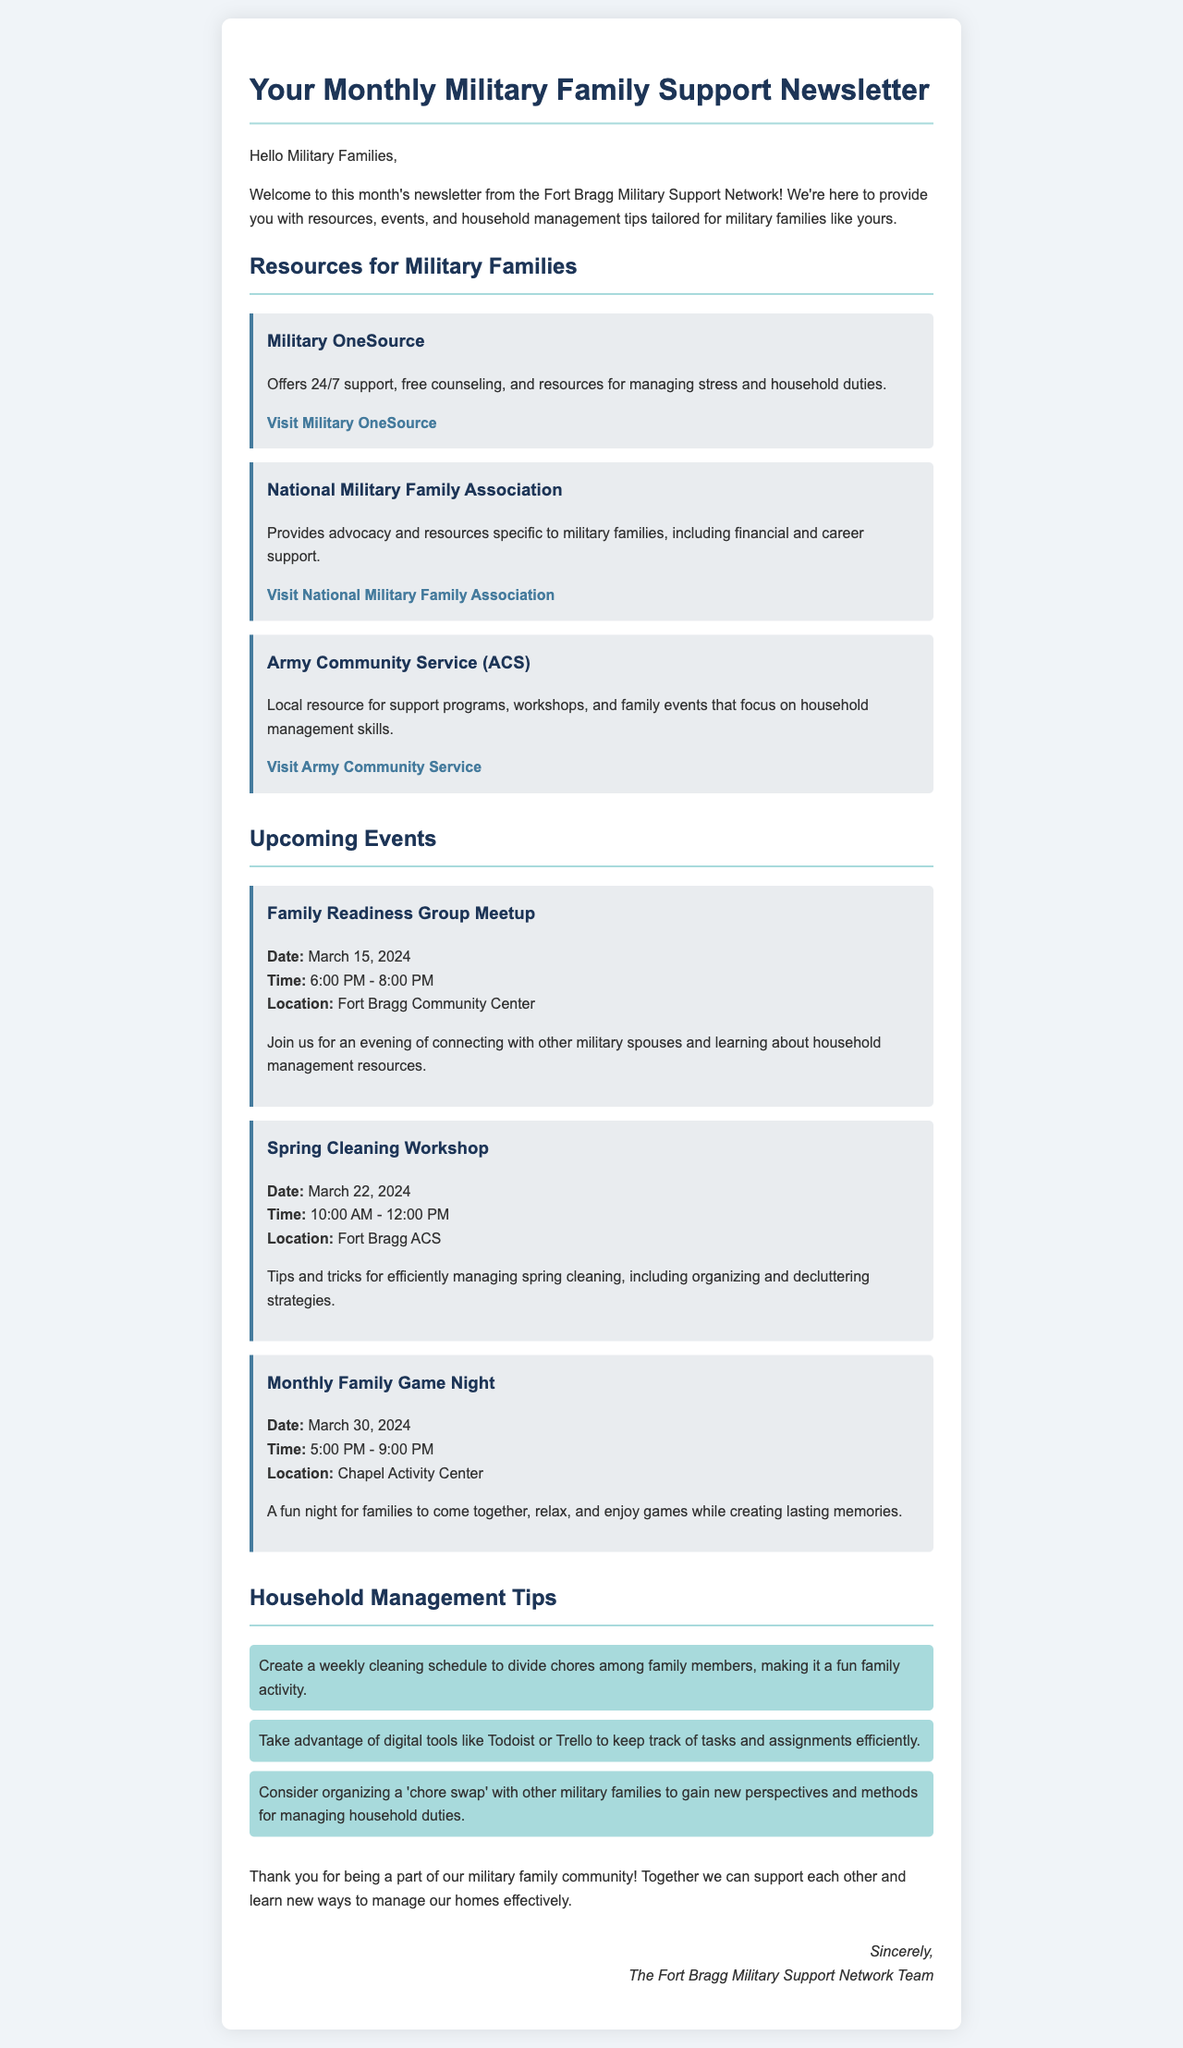What is the title of the newsletter? The title is prominently listed in the header of the document.
Answer: Your Monthly Military Family Support Newsletter What is the date of the Spring Cleaning Workshop? The Workshop date is specifically mentioned in the Upcoming Events section.
Answer: March 22, 2024 Which organization provides 24/7 support for military families? This information is found in the Resources for Military Families section of the document.
Answer: Military OneSource What time does the Family Readiness Group Meetup start? The start time is provided in the details under the Upcoming Events section.
Answer: 6:00 PM What household management tool is mentioned in the tips? This tool is listed as part of the Household Management Tips.
Answer: Todoist How many events are listed in the Upcoming Events section? The total number of events is counted from the event items provided.
Answer: Three What is a suggested strategy for managing chores according to the tips? This suggestion is described in the Household Management Tips section.
Answer: Create a weekly cleaning schedule What location hosts the Monthly Family Game Night? The location for the event is specified in the Upcoming Events section.
Answer: Chapel Activity Center 